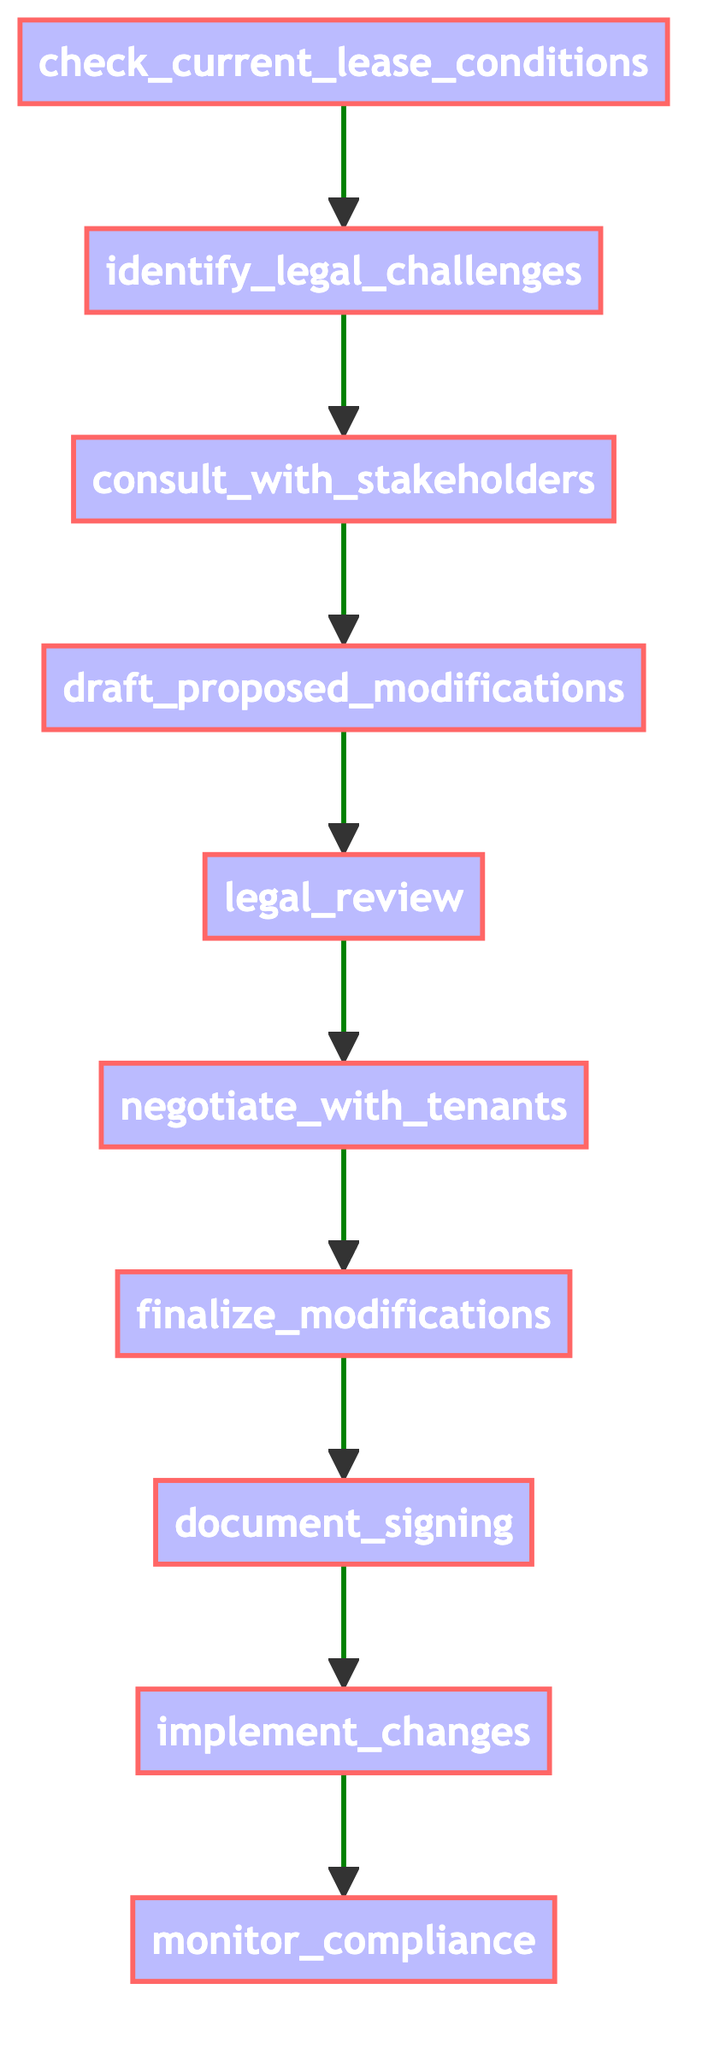What is the first step in the process? The first step clearly indicated in the diagram is labeled "check current lease conditions," making it the initial action taken in the flow.
Answer: check current lease conditions How many total steps are shown in the diagram? Counting all nodes from the beginning to the end, there are ten distinct steps represented in the diagram, detailing the process involved.
Answer: 10 Which step follows "legal review"? The diagram illustrates that the next step after "legal review" is "negotiate with tenants," showing the sequential flow of actions.
Answer: negotiate with tenants What is the last step in the process? The final action depicted in the flowchart is "monitor compliance," indicating it's the concluding step for the entire process detailed.
Answer: monitor compliance What is the step that occurs after "document signing"? The process flow demonstrates that "implement changes" is the subsequent step following "document signing," maintaining the logical progression.
Answer: implement changes How many steps involve stakeholder consultation? Analyzing the diagram, only one step includes stakeholder consultation, which is specifically "consult with stakeholders."
Answer: 1 Which step addresses legal compliance? The step titled "legal review" directly pertains to ensuring legal compliance with the proposed modifications made in the lease agreement.
Answer: legal review What is the relationship between "draft proposed modifications" and "negotiate with tenants"? The flow indicates that "draft proposed modifications" precedes "negotiate with tenants," suggesting that the drafting is a necessary foundation for negotiation.
Answer: draft proposed modifications precedes negotiate with tenants What is the primary goal of the step "finalize modifications"? The purpose of the "finalize modifications" step is to solidify the agreed-upon terms of the lease modifications ensuring they align with prior negotiations and legal checks.
Answer: solidify agreed-upon terms What type of flowchart is represented by the diagram? This diagram is a flowchart of a Python function, specifically designed to outline several sequential processes involved in lease modification negotiations.
Answer: flowchart of a Python function 